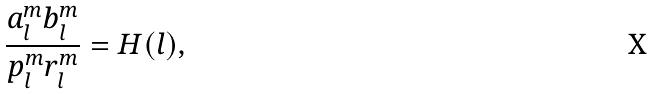Convert formula to latex. <formula><loc_0><loc_0><loc_500><loc_500>\frac { a _ { l } ^ { m } b _ { l } ^ { m } } { p _ { l } ^ { m } r _ { l } ^ { m } } = H ( l ) ,</formula> 